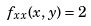Convert formula to latex. <formula><loc_0><loc_0><loc_500><loc_500>f _ { x x } ( x , y ) = 2</formula> 